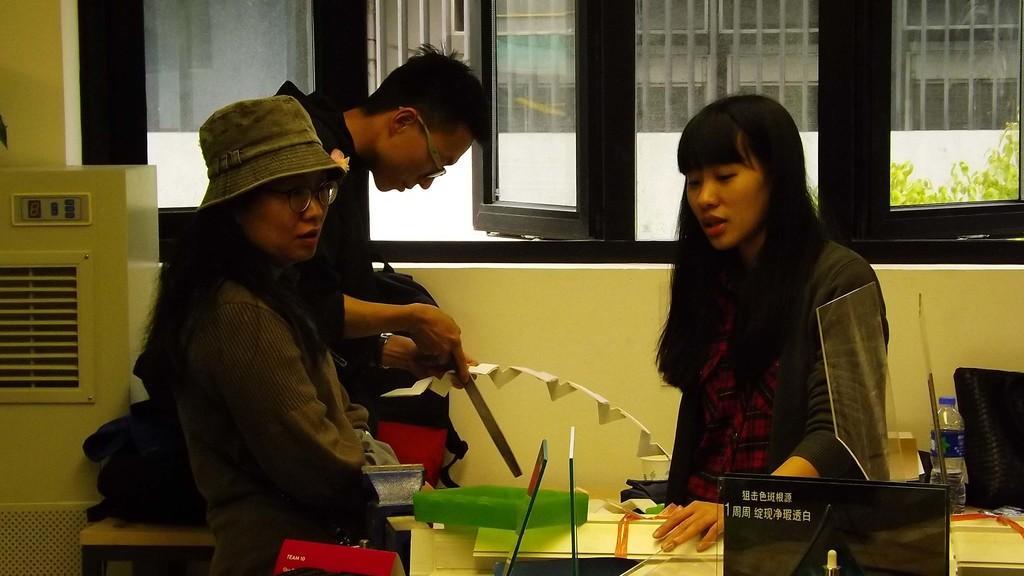How would you summarize this image in a sentence or two? In this image we can see the people standing near the table and the other person holding an object. On the table there are papers, bottle, board and a few objects. In the background, we can see the wall with the window, through the window we can see the building and a tree. 